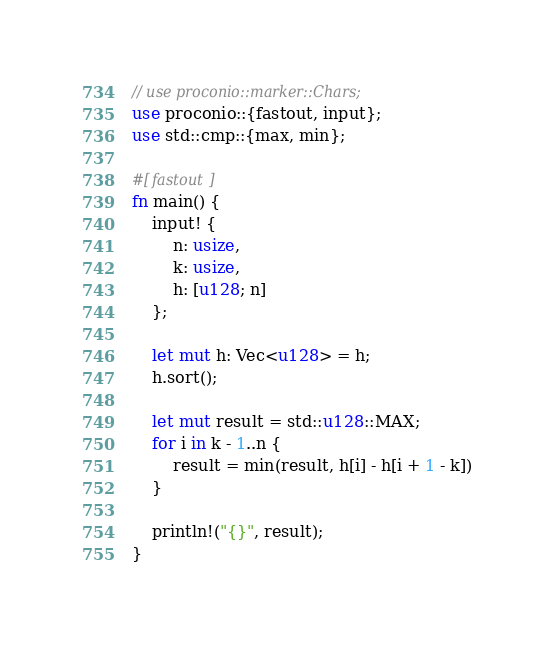<code> <loc_0><loc_0><loc_500><loc_500><_Rust_>// use proconio::marker::Chars;
use proconio::{fastout, input};
use std::cmp::{max, min};

#[fastout]
fn main() {
    input! {
        n: usize,
        k: usize,
        h: [u128; n]
    };

    let mut h: Vec<u128> = h;
    h.sort();

    let mut result = std::u128::MAX;
    for i in k - 1..n {
        result = min(result, h[i] - h[i + 1 - k])
    }

    println!("{}", result);
}
</code> 